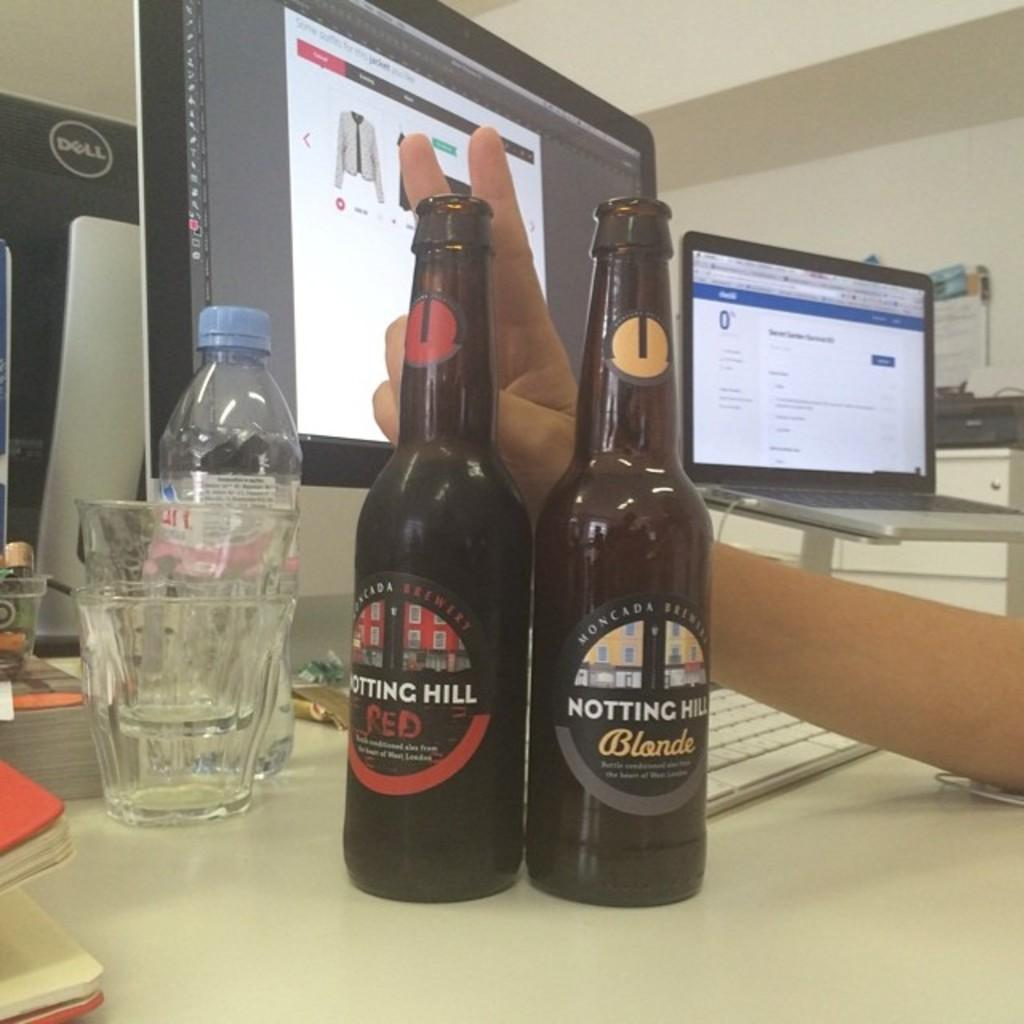What can be seen on the desk in the image? There are two wine bottles, two glasses, and one water bottle on the desk. What type of electronic devices are on the desk? There are two monitors on the desk. Is there any other computing device visible in the image? Yes, there is a laptop to the right of the desk. Can you describe the presence of a human element in the image? There is a human hand in the bottom right of the image. What type of trade is being conducted in the image? There is no indication of any trade being conducted in the image; it primarily features objects on a desk. Can you describe the woman in the image? There is no woman present in the image. 